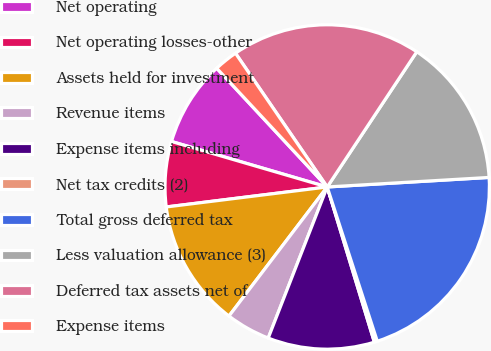<chart> <loc_0><loc_0><loc_500><loc_500><pie_chart><fcel>Net operating<fcel>Net operating losses-other<fcel>Assets held for investment<fcel>Revenue items<fcel>Expense items including<fcel>Net tax credits (2)<fcel>Total gross deferred tax<fcel>Less valuation allowance (3)<fcel>Deferred tax assets net of<fcel>Expense items<nl><fcel>8.55%<fcel>6.49%<fcel>12.68%<fcel>4.43%<fcel>10.62%<fcel>0.3%<fcel>20.94%<fcel>14.75%<fcel>18.88%<fcel>2.36%<nl></chart> 